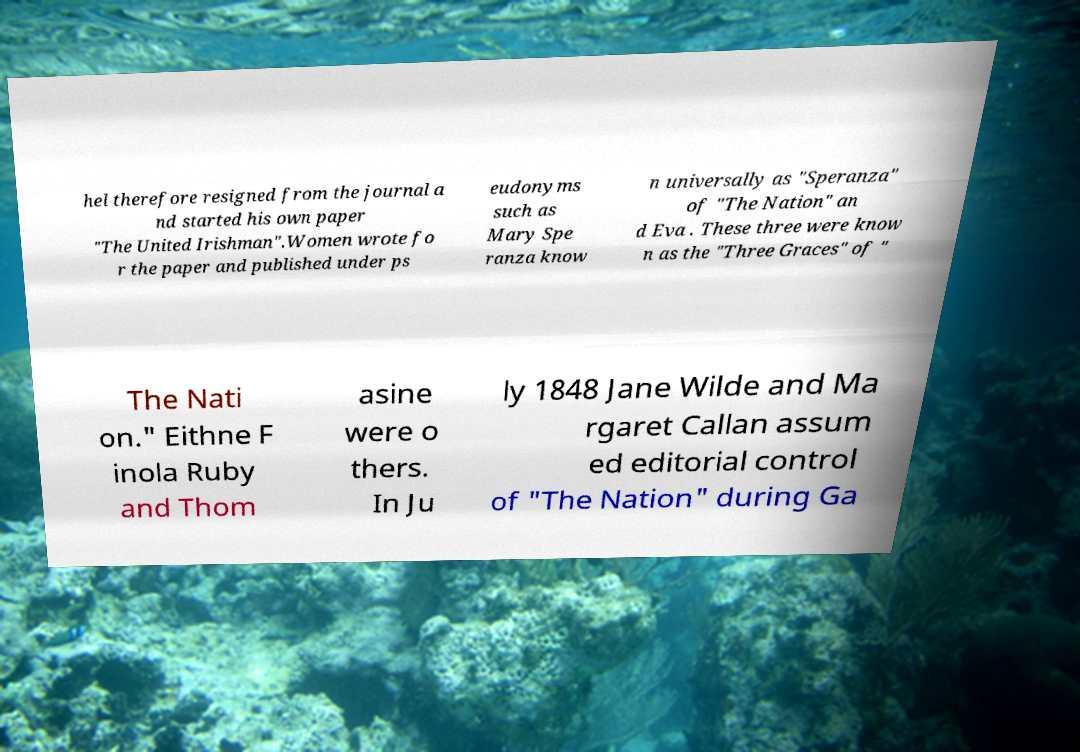What messages or text are displayed in this image? I need them in a readable, typed format. hel therefore resigned from the journal a nd started his own paper "The United Irishman".Women wrote fo r the paper and published under ps eudonyms such as Mary Spe ranza know n universally as "Speranza" of "The Nation" an d Eva . These three were know n as the "Three Graces" of " The Nati on." Eithne F inola Ruby and Thom asine were o thers. In Ju ly 1848 Jane Wilde and Ma rgaret Callan assum ed editorial control of "The Nation" during Ga 